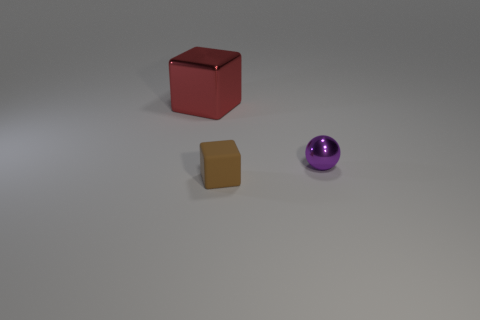Add 3 big cyan rubber objects. How many objects exist? 6 Subtract all blocks. How many objects are left? 1 Subtract all red cubes. Subtract all rubber things. How many objects are left? 1 Add 1 large metal cubes. How many large metal cubes are left? 2 Add 3 big red matte objects. How many big red matte objects exist? 3 Subtract 0 yellow blocks. How many objects are left? 3 